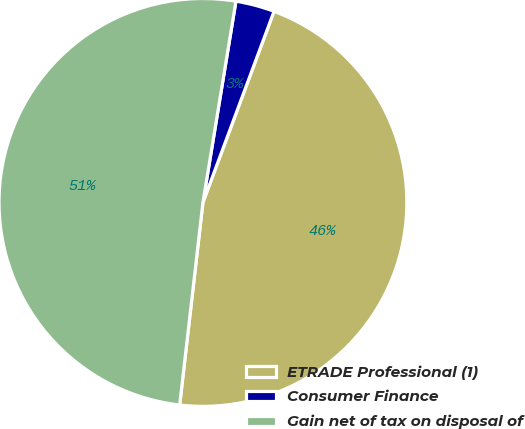<chart> <loc_0><loc_0><loc_500><loc_500><pie_chart><fcel>ETRADE Professional (1)<fcel>Consumer Finance<fcel>Gain net of tax on disposal of<nl><fcel>46.15%<fcel>3.08%<fcel>50.77%<nl></chart> 